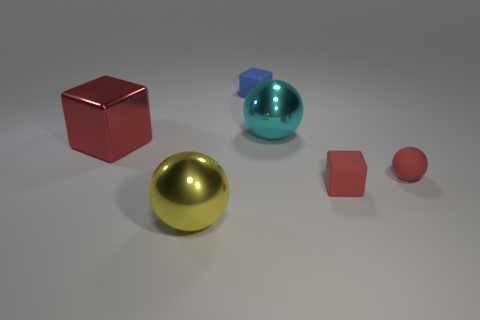Are there more tiny blue cubes in front of the large cyan metallic object than big shiny balls behind the tiny blue block?
Make the answer very short. No. What is the material of the thing that is both left of the blue rubber object and in front of the large block?
Keep it short and to the point. Metal. There is another matte object that is the same shape as the large yellow object; what is its color?
Offer a very short reply. Red. The cyan object has what size?
Give a very brief answer. Large. There is a small thing to the left of the tiny matte block that is right of the small blue object; what color is it?
Keep it short and to the point. Blue. What number of objects are in front of the large red shiny block and left of the small blue matte cube?
Ensure brevity in your answer.  1. Are there more red spheres than large objects?
Provide a succinct answer. No. What is the material of the large cyan sphere?
Provide a short and direct response. Metal. What number of spheres are behind the small rubber object left of the big cyan metal thing?
Your response must be concise. 0. There is a small rubber sphere; is it the same color as the cube that is in front of the large metal block?
Your response must be concise. Yes. 